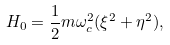Convert formula to latex. <formula><loc_0><loc_0><loc_500><loc_500>H _ { 0 } = \frac { 1 } { 2 } m \omega _ { c } ^ { 2 } ( \xi ^ { 2 } + \eta ^ { 2 } ) ,</formula> 